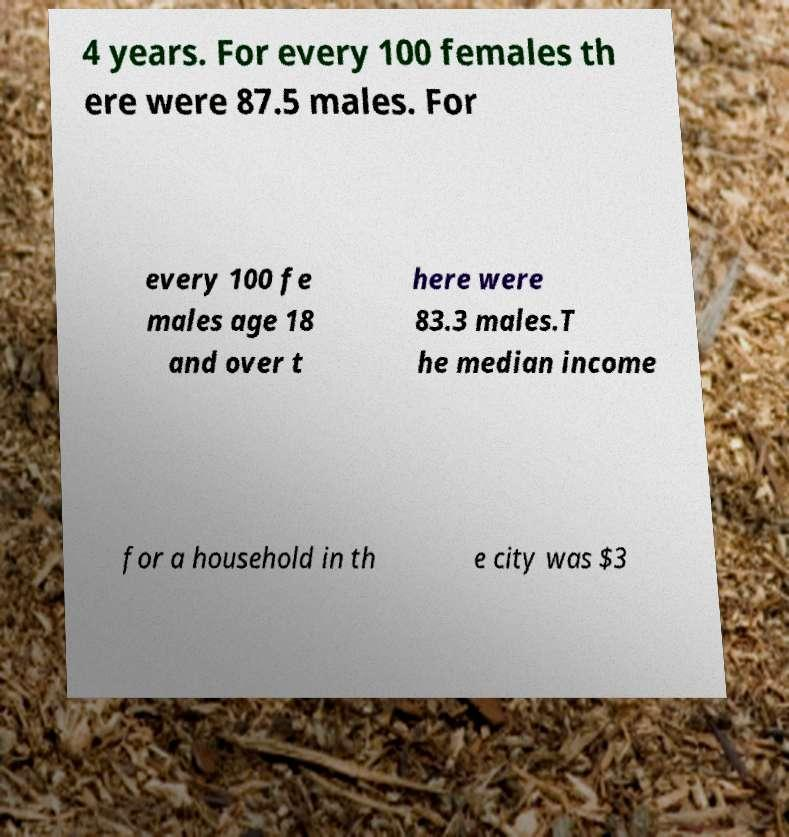Could you assist in decoding the text presented in this image and type it out clearly? 4 years. For every 100 females th ere were 87.5 males. For every 100 fe males age 18 and over t here were 83.3 males.T he median income for a household in th e city was $3 